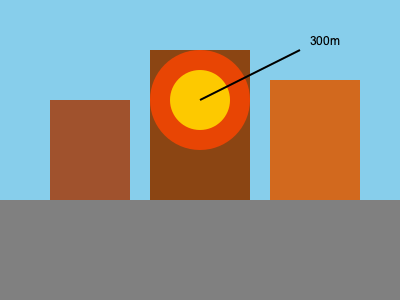Based on the cityscape image, estimate the diameter of the explosion fireball if the tallest building is known to be 150 meters high. To estimate the diameter of the explosion fireball, we'll follow these steps:

1. Identify the reference: The tallest building is 150 meters high.

2. Compare the fireball to the building:
   - The fireball appears to be roughly the same height as the tallest building.
   - Therefore, we can estimate the fireball's diameter to be approximately 150 meters.

3. Consider the perspective:
   - The fireball is likely closer to the viewer than the buildings.
   - This means it may appear larger than it actually is.

4. Account for atmospheric distortion:
   - Heat and smoke can make explosions appear larger.
   - We should slightly reduce our estimate.

5. Final estimation:
   - Given the above factors, we can estimate the fireball's diameter to be slightly less than the building's height.
   - A reasonable estimate would be about 80-90% of the building's height.

6. Calculate the final estimate:
   $$ 150 \text{ meters} \times 0.85 \approx 127.5 \text{ meters} $$

Rounding to the nearest 10 meters for practicality in film effects planning, we get 130 meters.
Answer: 130 meters 